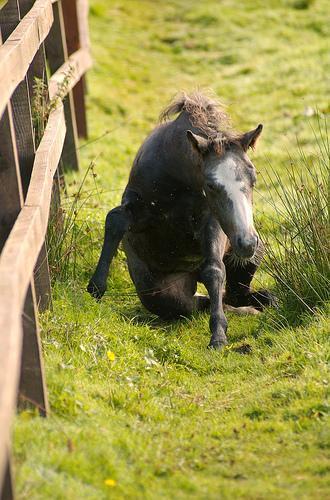How many people are looking at the camera?
Give a very brief answer. 0. 